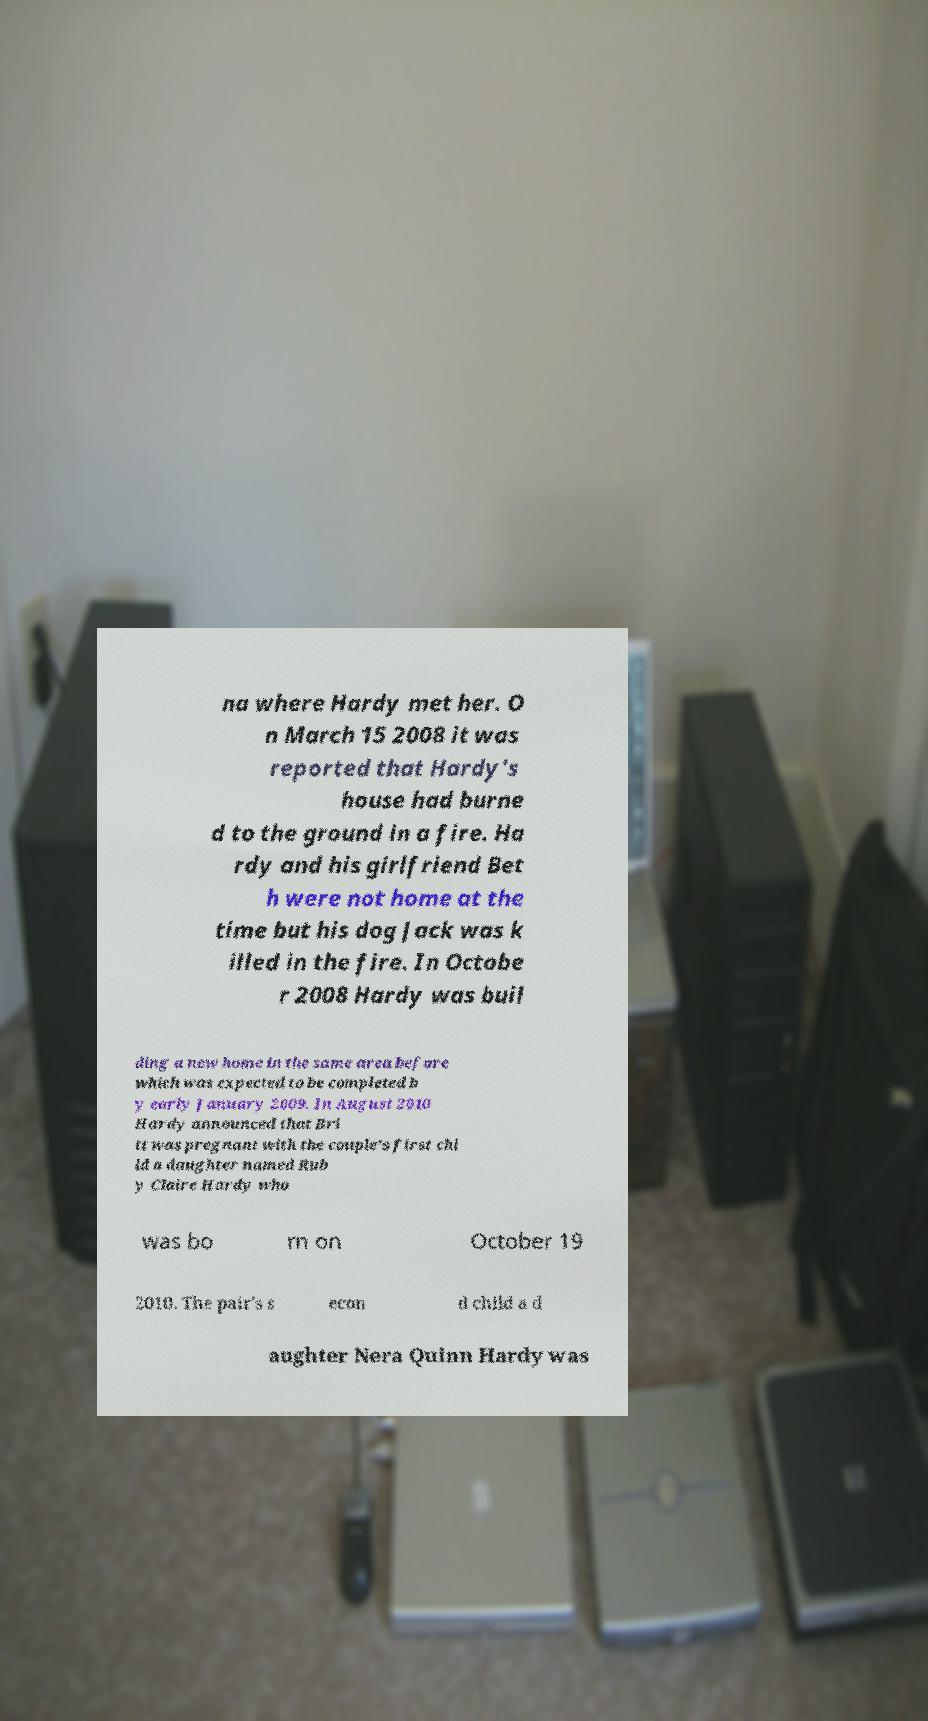There's text embedded in this image that I need extracted. Can you transcribe it verbatim? na where Hardy met her. O n March 15 2008 it was reported that Hardy's house had burne d to the ground in a fire. Ha rdy and his girlfriend Bet h were not home at the time but his dog Jack was k illed in the fire. In Octobe r 2008 Hardy was buil ding a new home in the same area before which was expected to be completed b y early January 2009. In August 2010 Hardy announced that Bri tt was pregnant with the couple's first chi ld a daughter named Rub y Claire Hardy who was bo rn on October 19 2010. The pair's s econ d child a d aughter Nera Quinn Hardy was 